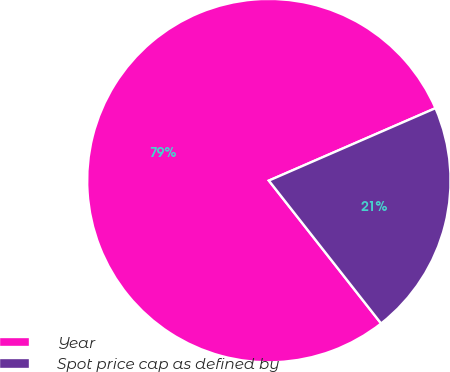Convert chart to OTSL. <chart><loc_0><loc_0><loc_500><loc_500><pie_chart><fcel>Year<fcel>Spot price cap as defined by<nl><fcel>79.07%<fcel>20.93%<nl></chart> 